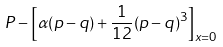<formula> <loc_0><loc_0><loc_500><loc_500>P - \left [ \alpha ( p - q ) + \frac { 1 } { 1 2 } ( p - q ) ^ { 3 } \right ] _ { x = 0 }</formula> 